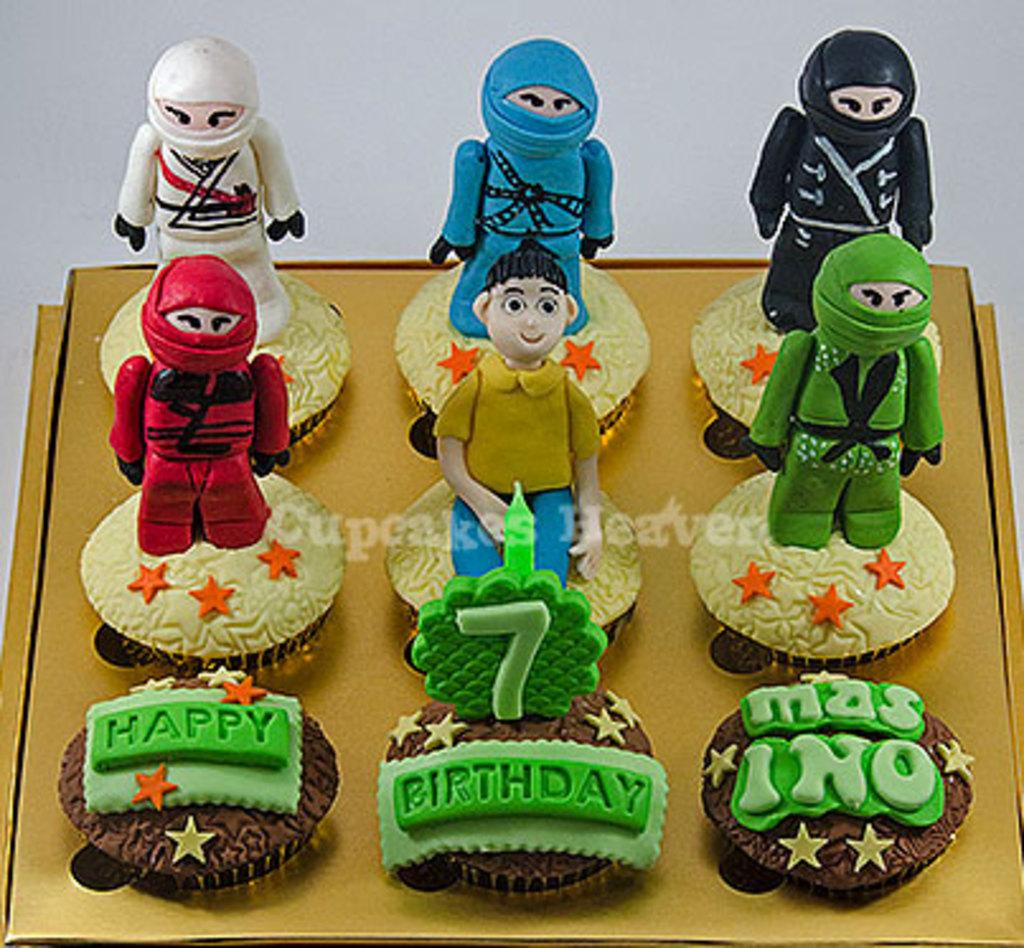How many cupcakes are visible in the image? There are nine cupcakes in the image. Where are the cupcakes located? The cupcakes are in a box. What can be seen on the cupcakes? There are cake decorating items on the cupcakes. Is there any text or logo visible in the image? Yes, there is a watermark in the middle of the image. How many ladybugs are crawling on the cupcakes in the image? There are no ladybugs present on the cupcakes in the image. What shape is the heart decoration on the cupcakes in the image? There is no heart decoration on the cupcakes in the image. 